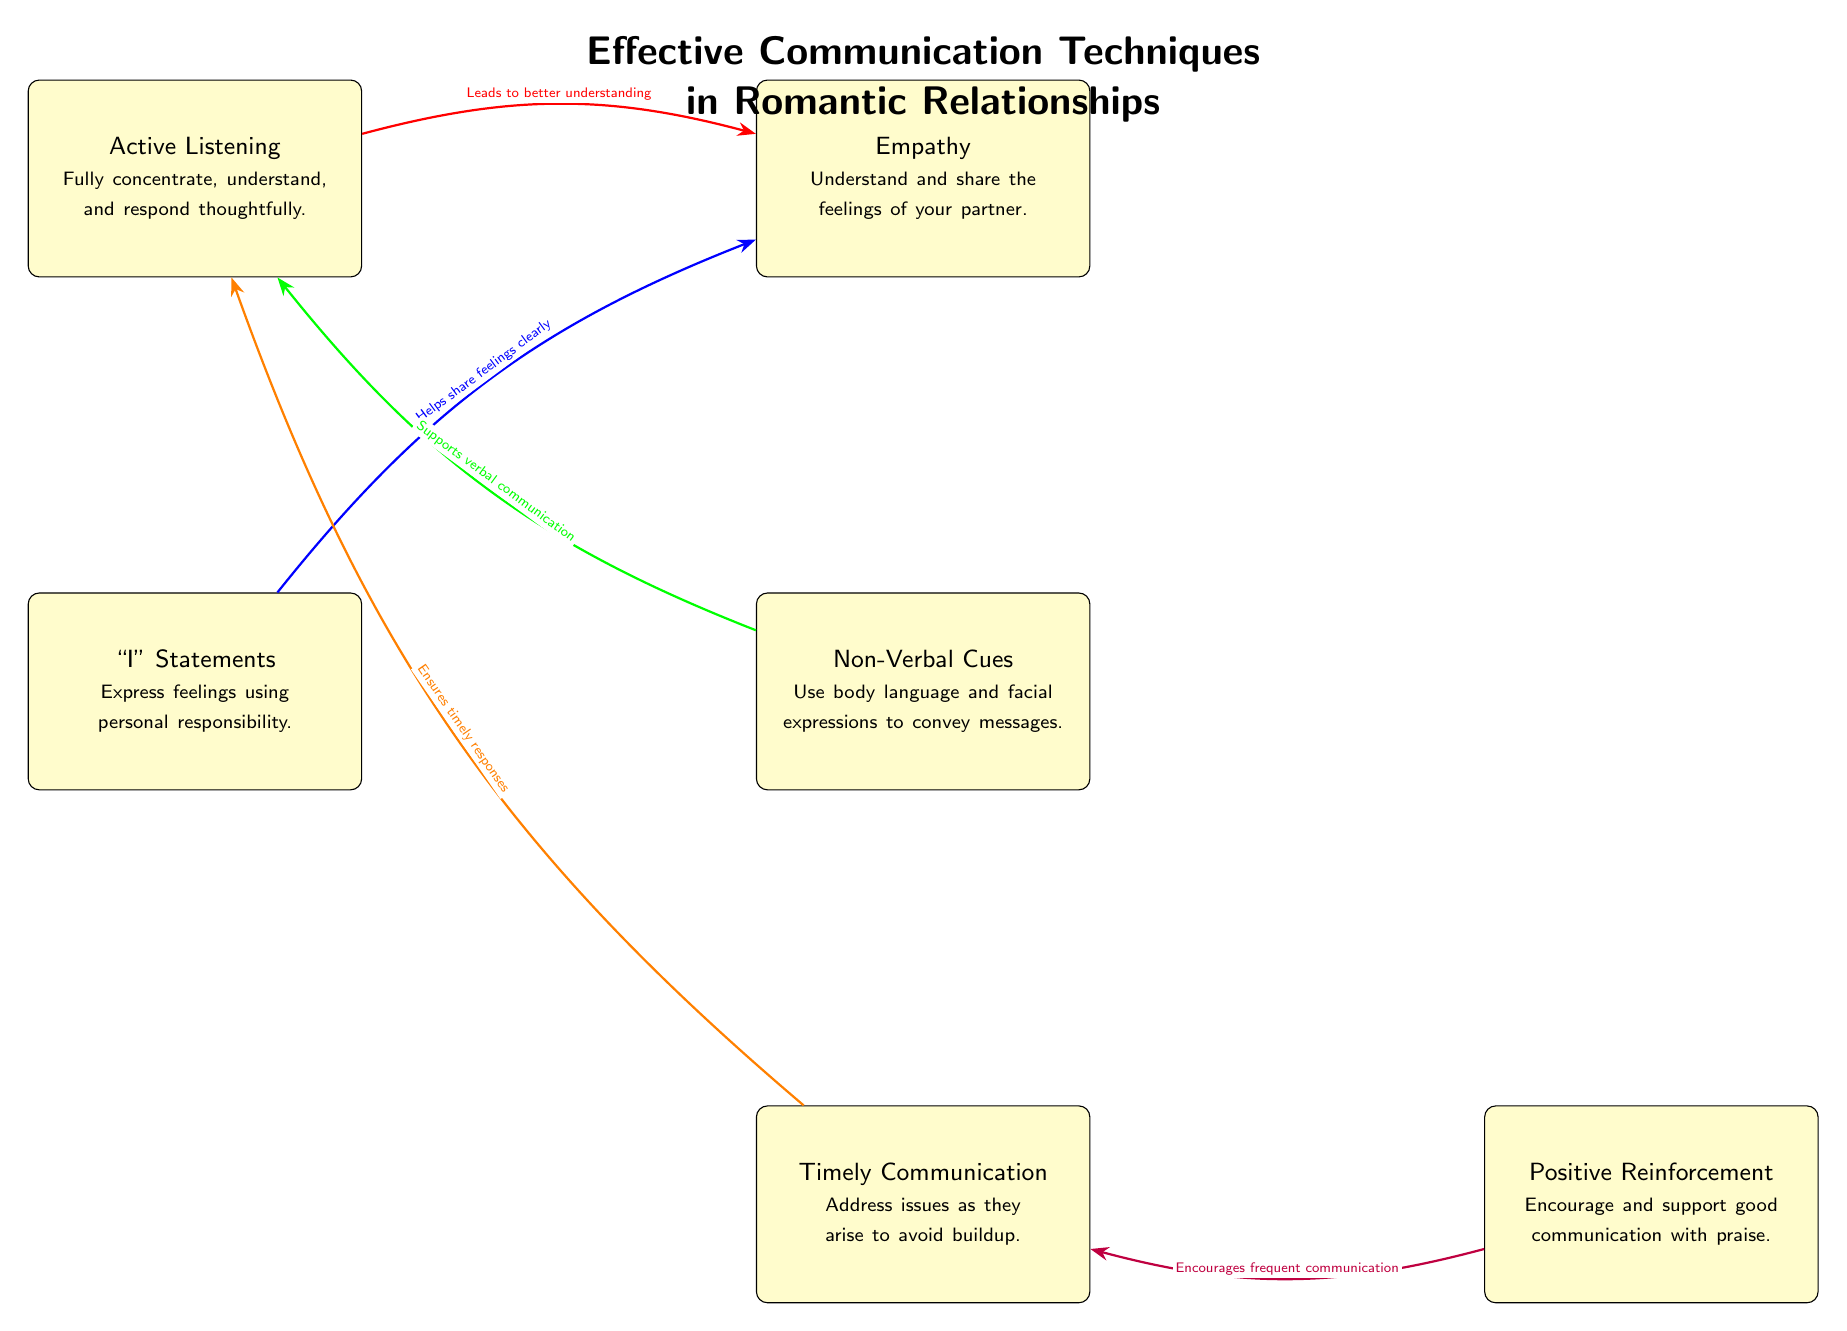What are the two primary techniques for effective communication shown at the top? The top two techniques displayed are "Active Listening" and "Empathy." These are the first nodes presented in the diagram.
Answer: Active Listening, Empathy How many total techniques are presented in the diagram? By counting each technique node in the diagram, we find there are six nodes: Active Listening, Empathy, "I" Statements, Non-Verbal Cues, Timely Communication, and Positive Reinforcement.
Answer: 6 Which technique is said to lead to better understanding? The arrow originates from "Active Listening" and points to "Empathy," indicating that "Active Listening" leads to a better understanding of the partner's feelings.
Answer: Active Listening What is the relationship between "I" Statements and "Empathy"? The arrow shows that "I" Statements help share feelings clearly, which in turn contributes to better "Empathy," signifying that expressing feelings through "I" Statements facilitates an empathetic response.
Answer: Helps share feelings clearly What technique supports verbal communication in the diagram? The diagram indicates that "Non-Verbal Cues" support "Active Listening," showing the importance of body language in effective communication.
Answer: Non-Verbal Cues Which technique encourages frequent communication according to the diagram? The arrow flows from "Positive Reinforcement" to "Timely Communication," indicating that using positive reinforcement encourages individuals to engage in communication more frequently.
Answer: Positive Reinforcement What type of communication does Timely Communication facilitate? The diagram indicates that "Timely Communication" ensures timely responses, which is crucial for addressing issues as they arise, indicating its role in facilitating responsive conversation.
Answer: Timely responses Which technique emphasizes personal responsibility in expressing feelings? The node for "I" Statements directly highlights the importance of expressing feelings with personal responsibility, distinguishing it as the technique that focuses on personal accountability.
Answer: "I" Statements 